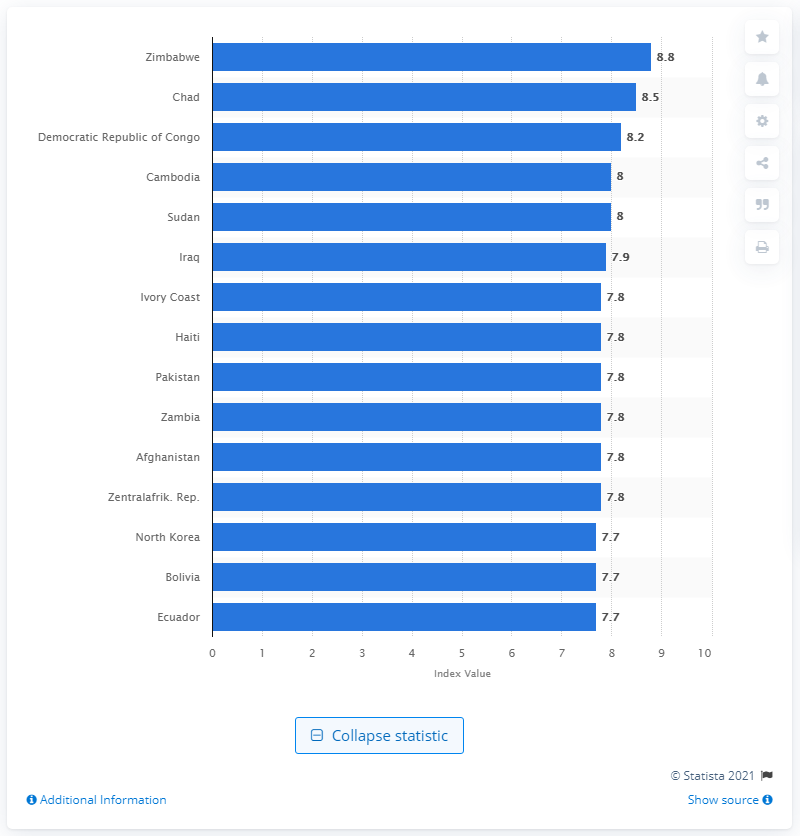Mention a couple of crucial points in this snapshot. In 2009 and 2010, Zimbabwe was the country that faced the highest level of political instability, making it a significant and concerning issue at the time. In 2009/2010, Zimbabwe's index value was 8.8. 